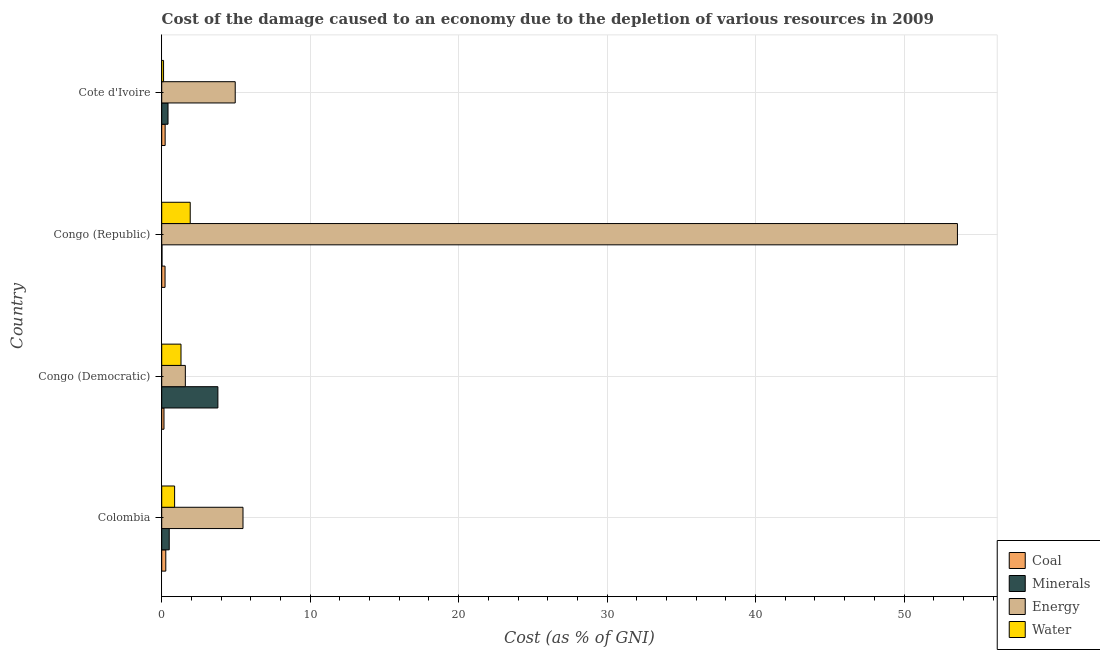How many different coloured bars are there?
Provide a succinct answer. 4. How many groups of bars are there?
Keep it short and to the point. 4. Are the number of bars on each tick of the Y-axis equal?
Give a very brief answer. Yes. How many bars are there on the 1st tick from the top?
Your answer should be very brief. 4. What is the label of the 2nd group of bars from the top?
Your answer should be compact. Congo (Republic). In how many cases, is the number of bars for a given country not equal to the number of legend labels?
Ensure brevity in your answer.  0. What is the cost of damage due to depletion of minerals in Congo (Republic)?
Your answer should be very brief. 0.02. Across all countries, what is the maximum cost of damage due to depletion of minerals?
Make the answer very short. 3.78. Across all countries, what is the minimum cost of damage due to depletion of minerals?
Ensure brevity in your answer.  0.02. In which country was the cost of damage due to depletion of coal maximum?
Your answer should be very brief. Colombia. In which country was the cost of damage due to depletion of water minimum?
Offer a terse response. Cote d'Ivoire. What is the total cost of damage due to depletion of water in the graph?
Give a very brief answer. 4.21. What is the difference between the cost of damage due to depletion of energy in Congo (Democratic) and that in Cote d'Ivoire?
Offer a very short reply. -3.36. What is the difference between the cost of damage due to depletion of minerals in Congo (Democratic) and the cost of damage due to depletion of water in Cote d'Ivoire?
Your answer should be very brief. 3.66. What is the average cost of damage due to depletion of energy per country?
Offer a very short reply. 16.4. What is the difference between the cost of damage due to depletion of coal and cost of damage due to depletion of water in Colombia?
Make the answer very short. -0.59. What is the ratio of the cost of damage due to depletion of coal in Congo (Republic) to that in Cote d'Ivoire?
Keep it short and to the point. 0.97. Is the cost of damage due to depletion of coal in Congo (Democratic) less than that in Cote d'Ivoire?
Your answer should be very brief. Yes. What is the difference between the highest and the second highest cost of damage due to depletion of coal?
Your answer should be compact. 0.04. What is the difference between the highest and the lowest cost of damage due to depletion of coal?
Offer a very short reply. 0.12. In how many countries, is the cost of damage due to depletion of energy greater than the average cost of damage due to depletion of energy taken over all countries?
Your answer should be compact. 1. Is it the case that in every country, the sum of the cost of damage due to depletion of water and cost of damage due to depletion of energy is greater than the sum of cost of damage due to depletion of coal and cost of damage due to depletion of minerals?
Your response must be concise. Yes. What does the 1st bar from the top in Congo (Republic) represents?
Your answer should be compact. Water. What does the 2nd bar from the bottom in Congo (Republic) represents?
Provide a succinct answer. Minerals. Are all the bars in the graph horizontal?
Offer a terse response. Yes. What is the difference between two consecutive major ticks on the X-axis?
Your response must be concise. 10. Are the values on the major ticks of X-axis written in scientific E-notation?
Offer a terse response. No. Does the graph contain any zero values?
Ensure brevity in your answer.  No. Where does the legend appear in the graph?
Your answer should be very brief. Bottom right. What is the title of the graph?
Keep it short and to the point. Cost of the damage caused to an economy due to the depletion of various resources in 2009 . Does "Secondary schools" appear as one of the legend labels in the graph?
Offer a very short reply. No. What is the label or title of the X-axis?
Offer a terse response. Cost (as % of GNI). What is the label or title of the Y-axis?
Ensure brevity in your answer.  Country. What is the Cost (as % of GNI) in Coal in Colombia?
Your answer should be very brief. 0.27. What is the Cost (as % of GNI) in Minerals in Colombia?
Make the answer very short. 0.51. What is the Cost (as % of GNI) in Energy in Colombia?
Your answer should be very brief. 5.48. What is the Cost (as % of GNI) in Water in Colombia?
Offer a very short reply. 0.87. What is the Cost (as % of GNI) of Coal in Congo (Democratic)?
Your answer should be very brief. 0.15. What is the Cost (as % of GNI) of Minerals in Congo (Democratic)?
Your answer should be compact. 3.78. What is the Cost (as % of GNI) in Energy in Congo (Democratic)?
Offer a very short reply. 1.59. What is the Cost (as % of GNI) in Water in Congo (Democratic)?
Your answer should be very brief. 1.3. What is the Cost (as % of GNI) in Coal in Congo (Republic)?
Provide a short and direct response. 0.22. What is the Cost (as % of GNI) of Minerals in Congo (Republic)?
Ensure brevity in your answer.  0.02. What is the Cost (as % of GNI) of Energy in Congo (Republic)?
Make the answer very short. 53.6. What is the Cost (as % of GNI) in Water in Congo (Republic)?
Make the answer very short. 1.92. What is the Cost (as % of GNI) in Coal in Cote d'Ivoire?
Offer a terse response. 0.23. What is the Cost (as % of GNI) in Minerals in Cote d'Ivoire?
Offer a terse response. 0.42. What is the Cost (as % of GNI) in Energy in Cote d'Ivoire?
Make the answer very short. 4.95. What is the Cost (as % of GNI) of Water in Cote d'Ivoire?
Provide a succinct answer. 0.12. Across all countries, what is the maximum Cost (as % of GNI) of Coal?
Provide a succinct answer. 0.27. Across all countries, what is the maximum Cost (as % of GNI) in Minerals?
Your answer should be very brief. 3.78. Across all countries, what is the maximum Cost (as % of GNI) of Energy?
Provide a succinct answer. 53.6. Across all countries, what is the maximum Cost (as % of GNI) in Water?
Your answer should be compact. 1.92. Across all countries, what is the minimum Cost (as % of GNI) of Coal?
Your answer should be compact. 0.15. Across all countries, what is the minimum Cost (as % of GNI) of Minerals?
Provide a short and direct response. 0.02. Across all countries, what is the minimum Cost (as % of GNI) of Energy?
Your response must be concise. 1.59. Across all countries, what is the minimum Cost (as % of GNI) of Water?
Provide a succinct answer. 0.12. What is the total Cost (as % of GNI) of Coal in the graph?
Make the answer very short. 0.88. What is the total Cost (as % of GNI) of Minerals in the graph?
Give a very brief answer. 4.73. What is the total Cost (as % of GNI) in Energy in the graph?
Your response must be concise. 65.61. What is the total Cost (as % of GNI) of Water in the graph?
Provide a succinct answer. 4.21. What is the difference between the Cost (as % of GNI) of Coal in Colombia and that in Congo (Democratic)?
Offer a terse response. 0.12. What is the difference between the Cost (as % of GNI) of Minerals in Colombia and that in Congo (Democratic)?
Offer a very short reply. -3.28. What is the difference between the Cost (as % of GNI) of Energy in Colombia and that in Congo (Democratic)?
Your response must be concise. 3.88. What is the difference between the Cost (as % of GNI) of Water in Colombia and that in Congo (Democratic)?
Provide a short and direct response. -0.43. What is the difference between the Cost (as % of GNI) in Coal in Colombia and that in Congo (Republic)?
Offer a very short reply. 0.05. What is the difference between the Cost (as % of GNI) in Minerals in Colombia and that in Congo (Republic)?
Provide a succinct answer. 0.49. What is the difference between the Cost (as % of GNI) in Energy in Colombia and that in Congo (Republic)?
Provide a short and direct response. -48.12. What is the difference between the Cost (as % of GNI) in Water in Colombia and that in Congo (Republic)?
Offer a very short reply. -1.05. What is the difference between the Cost (as % of GNI) of Coal in Colombia and that in Cote d'Ivoire?
Ensure brevity in your answer.  0.04. What is the difference between the Cost (as % of GNI) in Minerals in Colombia and that in Cote d'Ivoire?
Provide a succinct answer. 0.08. What is the difference between the Cost (as % of GNI) in Energy in Colombia and that in Cote d'Ivoire?
Ensure brevity in your answer.  0.52. What is the difference between the Cost (as % of GNI) of Water in Colombia and that in Cote d'Ivoire?
Provide a short and direct response. 0.74. What is the difference between the Cost (as % of GNI) of Coal in Congo (Democratic) and that in Congo (Republic)?
Provide a succinct answer. -0.07. What is the difference between the Cost (as % of GNI) in Minerals in Congo (Democratic) and that in Congo (Republic)?
Make the answer very short. 3.76. What is the difference between the Cost (as % of GNI) of Energy in Congo (Democratic) and that in Congo (Republic)?
Keep it short and to the point. -52. What is the difference between the Cost (as % of GNI) of Water in Congo (Democratic) and that in Congo (Republic)?
Keep it short and to the point. -0.62. What is the difference between the Cost (as % of GNI) of Coal in Congo (Democratic) and that in Cote d'Ivoire?
Provide a short and direct response. -0.08. What is the difference between the Cost (as % of GNI) in Minerals in Congo (Democratic) and that in Cote d'Ivoire?
Your answer should be very brief. 3.36. What is the difference between the Cost (as % of GNI) of Energy in Congo (Democratic) and that in Cote d'Ivoire?
Offer a very short reply. -3.36. What is the difference between the Cost (as % of GNI) of Water in Congo (Democratic) and that in Cote d'Ivoire?
Your response must be concise. 1.18. What is the difference between the Cost (as % of GNI) of Coal in Congo (Republic) and that in Cote d'Ivoire?
Your answer should be very brief. -0.01. What is the difference between the Cost (as % of GNI) of Minerals in Congo (Republic) and that in Cote d'Ivoire?
Give a very brief answer. -0.41. What is the difference between the Cost (as % of GNI) of Energy in Congo (Republic) and that in Cote d'Ivoire?
Your answer should be very brief. 48.64. What is the difference between the Cost (as % of GNI) of Water in Congo (Republic) and that in Cote d'Ivoire?
Ensure brevity in your answer.  1.8. What is the difference between the Cost (as % of GNI) in Coal in Colombia and the Cost (as % of GNI) in Minerals in Congo (Democratic)?
Your answer should be compact. -3.51. What is the difference between the Cost (as % of GNI) in Coal in Colombia and the Cost (as % of GNI) in Energy in Congo (Democratic)?
Offer a very short reply. -1.32. What is the difference between the Cost (as % of GNI) in Coal in Colombia and the Cost (as % of GNI) in Water in Congo (Democratic)?
Keep it short and to the point. -1.02. What is the difference between the Cost (as % of GNI) in Minerals in Colombia and the Cost (as % of GNI) in Energy in Congo (Democratic)?
Provide a short and direct response. -1.08. What is the difference between the Cost (as % of GNI) in Minerals in Colombia and the Cost (as % of GNI) in Water in Congo (Democratic)?
Your answer should be very brief. -0.79. What is the difference between the Cost (as % of GNI) of Energy in Colombia and the Cost (as % of GNI) of Water in Congo (Democratic)?
Your answer should be compact. 4.18. What is the difference between the Cost (as % of GNI) in Coal in Colombia and the Cost (as % of GNI) in Minerals in Congo (Republic)?
Your answer should be very brief. 0.26. What is the difference between the Cost (as % of GNI) in Coal in Colombia and the Cost (as % of GNI) in Energy in Congo (Republic)?
Your answer should be compact. -53.32. What is the difference between the Cost (as % of GNI) of Coal in Colombia and the Cost (as % of GNI) of Water in Congo (Republic)?
Keep it short and to the point. -1.65. What is the difference between the Cost (as % of GNI) of Minerals in Colombia and the Cost (as % of GNI) of Energy in Congo (Republic)?
Provide a succinct answer. -53.09. What is the difference between the Cost (as % of GNI) of Minerals in Colombia and the Cost (as % of GNI) of Water in Congo (Republic)?
Keep it short and to the point. -1.41. What is the difference between the Cost (as % of GNI) of Energy in Colombia and the Cost (as % of GNI) of Water in Congo (Republic)?
Provide a succinct answer. 3.55. What is the difference between the Cost (as % of GNI) in Coal in Colombia and the Cost (as % of GNI) in Minerals in Cote d'Ivoire?
Provide a succinct answer. -0.15. What is the difference between the Cost (as % of GNI) in Coal in Colombia and the Cost (as % of GNI) in Energy in Cote d'Ivoire?
Your answer should be very brief. -4.68. What is the difference between the Cost (as % of GNI) in Coal in Colombia and the Cost (as % of GNI) in Water in Cote d'Ivoire?
Provide a short and direct response. 0.15. What is the difference between the Cost (as % of GNI) of Minerals in Colombia and the Cost (as % of GNI) of Energy in Cote d'Ivoire?
Your response must be concise. -4.44. What is the difference between the Cost (as % of GNI) of Minerals in Colombia and the Cost (as % of GNI) of Water in Cote d'Ivoire?
Keep it short and to the point. 0.38. What is the difference between the Cost (as % of GNI) in Energy in Colombia and the Cost (as % of GNI) in Water in Cote d'Ivoire?
Your answer should be compact. 5.35. What is the difference between the Cost (as % of GNI) in Coal in Congo (Democratic) and the Cost (as % of GNI) in Minerals in Congo (Republic)?
Offer a very short reply. 0.13. What is the difference between the Cost (as % of GNI) in Coal in Congo (Democratic) and the Cost (as % of GNI) in Energy in Congo (Republic)?
Provide a short and direct response. -53.44. What is the difference between the Cost (as % of GNI) in Coal in Congo (Democratic) and the Cost (as % of GNI) in Water in Congo (Republic)?
Give a very brief answer. -1.77. What is the difference between the Cost (as % of GNI) of Minerals in Congo (Democratic) and the Cost (as % of GNI) of Energy in Congo (Republic)?
Make the answer very short. -49.81. What is the difference between the Cost (as % of GNI) of Minerals in Congo (Democratic) and the Cost (as % of GNI) of Water in Congo (Republic)?
Keep it short and to the point. 1.86. What is the difference between the Cost (as % of GNI) of Energy in Congo (Democratic) and the Cost (as % of GNI) of Water in Congo (Republic)?
Keep it short and to the point. -0.33. What is the difference between the Cost (as % of GNI) of Coal in Congo (Democratic) and the Cost (as % of GNI) of Minerals in Cote d'Ivoire?
Keep it short and to the point. -0.27. What is the difference between the Cost (as % of GNI) in Coal in Congo (Democratic) and the Cost (as % of GNI) in Energy in Cote d'Ivoire?
Your answer should be very brief. -4.8. What is the difference between the Cost (as % of GNI) in Coal in Congo (Democratic) and the Cost (as % of GNI) in Water in Cote d'Ivoire?
Your answer should be very brief. 0.03. What is the difference between the Cost (as % of GNI) of Minerals in Congo (Democratic) and the Cost (as % of GNI) of Energy in Cote d'Ivoire?
Offer a very short reply. -1.17. What is the difference between the Cost (as % of GNI) of Minerals in Congo (Democratic) and the Cost (as % of GNI) of Water in Cote d'Ivoire?
Your answer should be very brief. 3.66. What is the difference between the Cost (as % of GNI) of Energy in Congo (Democratic) and the Cost (as % of GNI) of Water in Cote d'Ivoire?
Your response must be concise. 1.47. What is the difference between the Cost (as % of GNI) in Coal in Congo (Republic) and the Cost (as % of GNI) in Minerals in Cote d'Ivoire?
Your answer should be compact. -0.2. What is the difference between the Cost (as % of GNI) of Coal in Congo (Republic) and the Cost (as % of GNI) of Energy in Cote d'Ivoire?
Ensure brevity in your answer.  -4.73. What is the difference between the Cost (as % of GNI) in Minerals in Congo (Republic) and the Cost (as % of GNI) in Energy in Cote d'Ivoire?
Ensure brevity in your answer.  -4.93. What is the difference between the Cost (as % of GNI) in Minerals in Congo (Republic) and the Cost (as % of GNI) in Water in Cote d'Ivoire?
Your answer should be very brief. -0.11. What is the difference between the Cost (as % of GNI) in Energy in Congo (Republic) and the Cost (as % of GNI) in Water in Cote d'Ivoire?
Keep it short and to the point. 53.47. What is the average Cost (as % of GNI) of Coal per country?
Your answer should be very brief. 0.22. What is the average Cost (as % of GNI) of Minerals per country?
Keep it short and to the point. 1.18. What is the average Cost (as % of GNI) of Energy per country?
Provide a short and direct response. 16.4. What is the average Cost (as % of GNI) of Water per country?
Ensure brevity in your answer.  1.05. What is the difference between the Cost (as % of GNI) of Coal and Cost (as % of GNI) of Minerals in Colombia?
Give a very brief answer. -0.23. What is the difference between the Cost (as % of GNI) of Coal and Cost (as % of GNI) of Energy in Colombia?
Your response must be concise. -5.2. What is the difference between the Cost (as % of GNI) of Coal and Cost (as % of GNI) of Water in Colombia?
Keep it short and to the point. -0.59. What is the difference between the Cost (as % of GNI) in Minerals and Cost (as % of GNI) in Energy in Colombia?
Provide a succinct answer. -4.97. What is the difference between the Cost (as % of GNI) of Minerals and Cost (as % of GNI) of Water in Colombia?
Your answer should be very brief. -0.36. What is the difference between the Cost (as % of GNI) of Energy and Cost (as % of GNI) of Water in Colombia?
Your answer should be very brief. 4.61. What is the difference between the Cost (as % of GNI) of Coal and Cost (as % of GNI) of Minerals in Congo (Democratic)?
Ensure brevity in your answer.  -3.63. What is the difference between the Cost (as % of GNI) of Coal and Cost (as % of GNI) of Energy in Congo (Democratic)?
Keep it short and to the point. -1.44. What is the difference between the Cost (as % of GNI) of Coal and Cost (as % of GNI) of Water in Congo (Democratic)?
Offer a very short reply. -1.15. What is the difference between the Cost (as % of GNI) in Minerals and Cost (as % of GNI) in Energy in Congo (Democratic)?
Make the answer very short. 2.19. What is the difference between the Cost (as % of GNI) of Minerals and Cost (as % of GNI) of Water in Congo (Democratic)?
Give a very brief answer. 2.48. What is the difference between the Cost (as % of GNI) in Energy and Cost (as % of GNI) in Water in Congo (Democratic)?
Offer a very short reply. 0.29. What is the difference between the Cost (as % of GNI) in Coal and Cost (as % of GNI) in Minerals in Congo (Republic)?
Your answer should be very brief. 0.21. What is the difference between the Cost (as % of GNI) of Coal and Cost (as % of GNI) of Energy in Congo (Republic)?
Provide a short and direct response. -53.37. What is the difference between the Cost (as % of GNI) of Coal and Cost (as % of GNI) of Water in Congo (Republic)?
Provide a succinct answer. -1.7. What is the difference between the Cost (as % of GNI) of Minerals and Cost (as % of GNI) of Energy in Congo (Republic)?
Provide a short and direct response. -53.58. What is the difference between the Cost (as % of GNI) of Minerals and Cost (as % of GNI) of Water in Congo (Republic)?
Provide a succinct answer. -1.9. What is the difference between the Cost (as % of GNI) of Energy and Cost (as % of GNI) of Water in Congo (Republic)?
Offer a very short reply. 51.67. What is the difference between the Cost (as % of GNI) in Coal and Cost (as % of GNI) in Minerals in Cote d'Ivoire?
Make the answer very short. -0.19. What is the difference between the Cost (as % of GNI) of Coal and Cost (as % of GNI) of Energy in Cote d'Ivoire?
Your answer should be very brief. -4.72. What is the difference between the Cost (as % of GNI) in Coal and Cost (as % of GNI) in Water in Cote d'Ivoire?
Offer a very short reply. 0.11. What is the difference between the Cost (as % of GNI) of Minerals and Cost (as % of GNI) of Energy in Cote d'Ivoire?
Give a very brief answer. -4.53. What is the difference between the Cost (as % of GNI) in Minerals and Cost (as % of GNI) in Water in Cote d'Ivoire?
Keep it short and to the point. 0.3. What is the difference between the Cost (as % of GNI) in Energy and Cost (as % of GNI) in Water in Cote d'Ivoire?
Provide a short and direct response. 4.83. What is the ratio of the Cost (as % of GNI) in Coal in Colombia to that in Congo (Democratic)?
Offer a very short reply. 1.8. What is the ratio of the Cost (as % of GNI) of Minerals in Colombia to that in Congo (Democratic)?
Your answer should be very brief. 0.13. What is the ratio of the Cost (as % of GNI) in Energy in Colombia to that in Congo (Democratic)?
Offer a terse response. 3.44. What is the ratio of the Cost (as % of GNI) of Water in Colombia to that in Congo (Democratic)?
Your response must be concise. 0.67. What is the ratio of the Cost (as % of GNI) of Coal in Colombia to that in Congo (Republic)?
Provide a succinct answer. 1.22. What is the ratio of the Cost (as % of GNI) in Minerals in Colombia to that in Congo (Republic)?
Offer a terse response. 26.15. What is the ratio of the Cost (as % of GNI) in Energy in Colombia to that in Congo (Republic)?
Provide a short and direct response. 0.1. What is the ratio of the Cost (as % of GNI) in Water in Colombia to that in Congo (Republic)?
Make the answer very short. 0.45. What is the ratio of the Cost (as % of GNI) of Coal in Colombia to that in Cote d'Ivoire?
Your answer should be compact. 1.19. What is the ratio of the Cost (as % of GNI) in Minerals in Colombia to that in Cote d'Ivoire?
Give a very brief answer. 1.19. What is the ratio of the Cost (as % of GNI) of Energy in Colombia to that in Cote d'Ivoire?
Provide a succinct answer. 1.11. What is the ratio of the Cost (as % of GNI) of Water in Colombia to that in Cote d'Ivoire?
Keep it short and to the point. 6.98. What is the ratio of the Cost (as % of GNI) in Coal in Congo (Democratic) to that in Congo (Republic)?
Provide a short and direct response. 0.68. What is the ratio of the Cost (as % of GNI) in Minerals in Congo (Democratic) to that in Congo (Republic)?
Your response must be concise. 195.24. What is the ratio of the Cost (as % of GNI) of Energy in Congo (Democratic) to that in Congo (Republic)?
Your answer should be very brief. 0.03. What is the ratio of the Cost (as % of GNI) of Water in Congo (Democratic) to that in Congo (Republic)?
Give a very brief answer. 0.68. What is the ratio of the Cost (as % of GNI) of Coal in Congo (Democratic) to that in Cote d'Ivoire?
Offer a very short reply. 0.66. What is the ratio of the Cost (as % of GNI) in Minerals in Congo (Democratic) to that in Cote d'Ivoire?
Provide a short and direct response. 8.91. What is the ratio of the Cost (as % of GNI) of Energy in Congo (Democratic) to that in Cote d'Ivoire?
Your answer should be very brief. 0.32. What is the ratio of the Cost (as % of GNI) of Water in Congo (Democratic) to that in Cote d'Ivoire?
Your answer should be compact. 10.44. What is the ratio of the Cost (as % of GNI) of Coal in Congo (Republic) to that in Cote d'Ivoire?
Your answer should be compact. 0.97. What is the ratio of the Cost (as % of GNI) in Minerals in Congo (Republic) to that in Cote d'Ivoire?
Your response must be concise. 0.05. What is the ratio of the Cost (as % of GNI) in Energy in Congo (Republic) to that in Cote d'Ivoire?
Keep it short and to the point. 10.82. What is the ratio of the Cost (as % of GNI) of Water in Congo (Republic) to that in Cote d'Ivoire?
Keep it short and to the point. 15.43. What is the difference between the highest and the second highest Cost (as % of GNI) of Coal?
Make the answer very short. 0.04. What is the difference between the highest and the second highest Cost (as % of GNI) in Minerals?
Make the answer very short. 3.28. What is the difference between the highest and the second highest Cost (as % of GNI) of Energy?
Make the answer very short. 48.12. What is the difference between the highest and the second highest Cost (as % of GNI) in Water?
Make the answer very short. 0.62. What is the difference between the highest and the lowest Cost (as % of GNI) in Coal?
Provide a succinct answer. 0.12. What is the difference between the highest and the lowest Cost (as % of GNI) in Minerals?
Your response must be concise. 3.76. What is the difference between the highest and the lowest Cost (as % of GNI) of Energy?
Offer a terse response. 52. What is the difference between the highest and the lowest Cost (as % of GNI) in Water?
Your response must be concise. 1.8. 